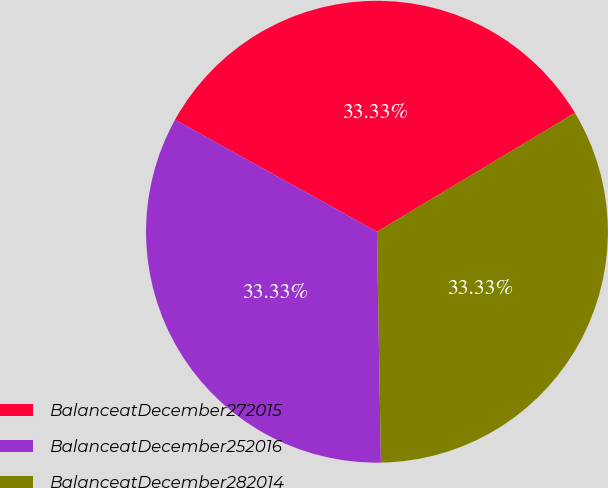<chart> <loc_0><loc_0><loc_500><loc_500><pie_chart><fcel>BalanceatDecember272015<fcel>BalanceatDecember252016<fcel>BalanceatDecember282014<nl><fcel>33.33%<fcel>33.33%<fcel>33.33%<nl></chart> 